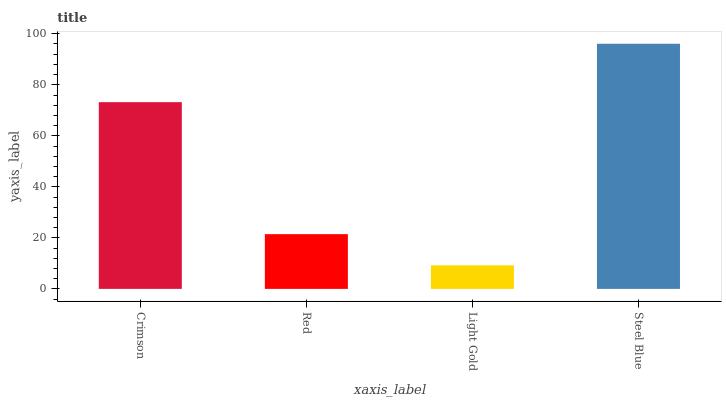Is Light Gold the minimum?
Answer yes or no. Yes. Is Steel Blue the maximum?
Answer yes or no. Yes. Is Red the minimum?
Answer yes or no. No. Is Red the maximum?
Answer yes or no. No. Is Crimson greater than Red?
Answer yes or no. Yes. Is Red less than Crimson?
Answer yes or no. Yes. Is Red greater than Crimson?
Answer yes or no. No. Is Crimson less than Red?
Answer yes or no. No. Is Crimson the high median?
Answer yes or no. Yes. Is Red the low median?
Answer yes or no. Yes. Is Light Gold the high median?
Answer yes or no. No. Is Steel Blue the low median?
Answer yes or no. No. 